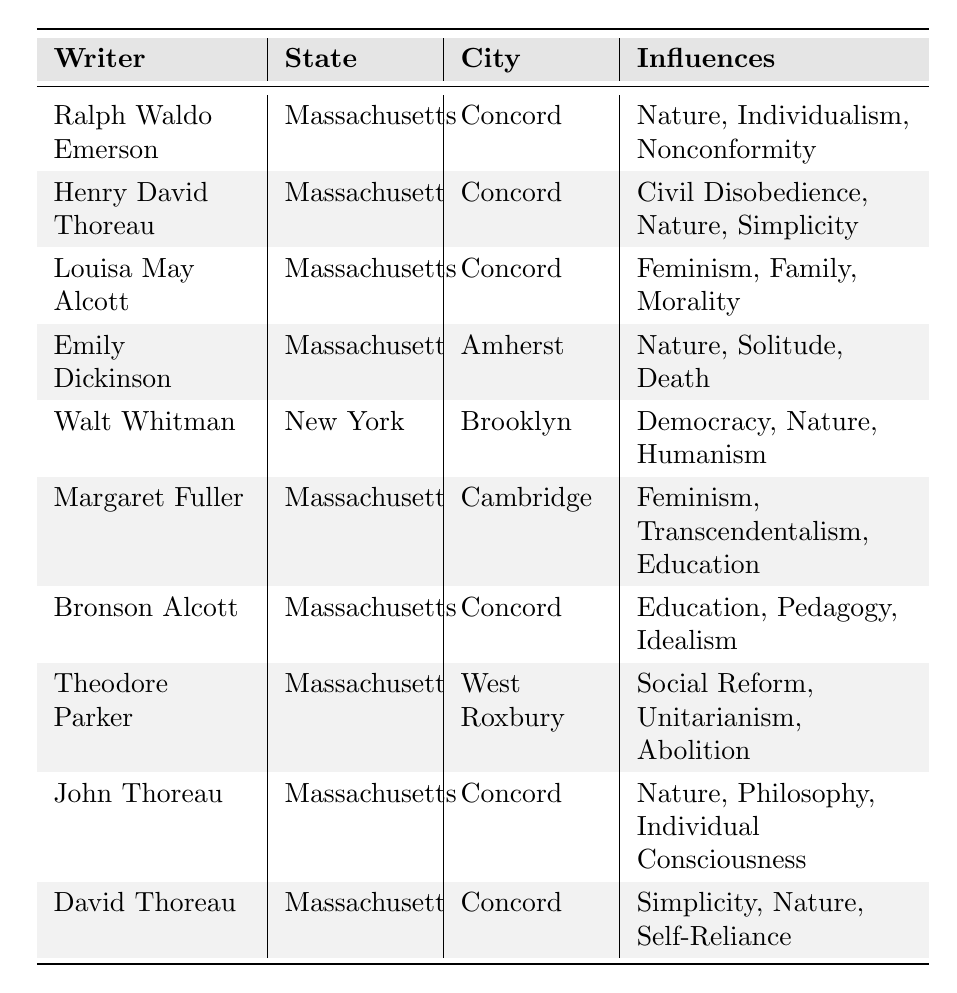What are the names of the transcendentalist writers from Massachusetts? The table lists the writers from Massachusetts: Ralph Waldo Emerson, Henry David Thoreau, Louisa May Alcott, Emily Dickinson, Margaret Fuller, Bronson Alcott, Theodore Parker, John Thoreau, and David Thoreau.
Answer: Ralph Waldo Emerson, Henry David Thoreau, Louisa May Alcott, Emily Dickinson, Margaret Fuller, Bronson Alcott, Theodore Parker, John Thoreau, David Thoreau Which writer is associated with the city of Amherst? According to the data, Emily Dickinson is the only writer listed under the city of Amherst.
Answer: Emily Dickinson How many writers listed in the table are influenced by 'Nature'? The writers influenced by 'Nature' include Ralph Waldo Emerson, Henry David Thoreau, Emily Dickinson, Walt Whitman, John Thoreau, and David Thoreau. Counting these gives a total of 6.
Answer: 6 Is there a writer from New York in the table? The table includes Walt Whitman as the only writer from New York. Therefore, the answer is yes.
Answer: Yes What influence is shared between Ralph Waldo Emerson and Henry David Thoreau? Both writers are influenced by 'Nature', as listed in their respective influence descriptions.
Answer: Nature How many different cities are mentioned for transcendentalist writers? The cities listed are Concord, Amherst, Brooklyn, and Cambridge, totaling 4 different cities.
Answer: 4 Which state has the most transcendentalist writers represented in the table? Massachusetts has 9 writers listed while New York has only 1 writer. So, Massachusetts has the most.
Answer: Massachusetts What are the influences of Louisa May Alcott? Louisa May Alcott is influenced by Feminism, Family, and Morality as indicated in her row of the table.
Answer: Feminism, Family, Morality Do any writers in the table share the same street as Ralph Waldo Emerson? Since there are no specific streets mentioned in the data, we cannot determine any shared streets. The influence refers only to cities and states.
Answer: No Which writer has the influence of 'Education'? The influence of 'Education' is associated with Margaret Fuller and Bronson Alcott as derived from the table.
Answer: Margaret Fuller, Bronson Alcott 